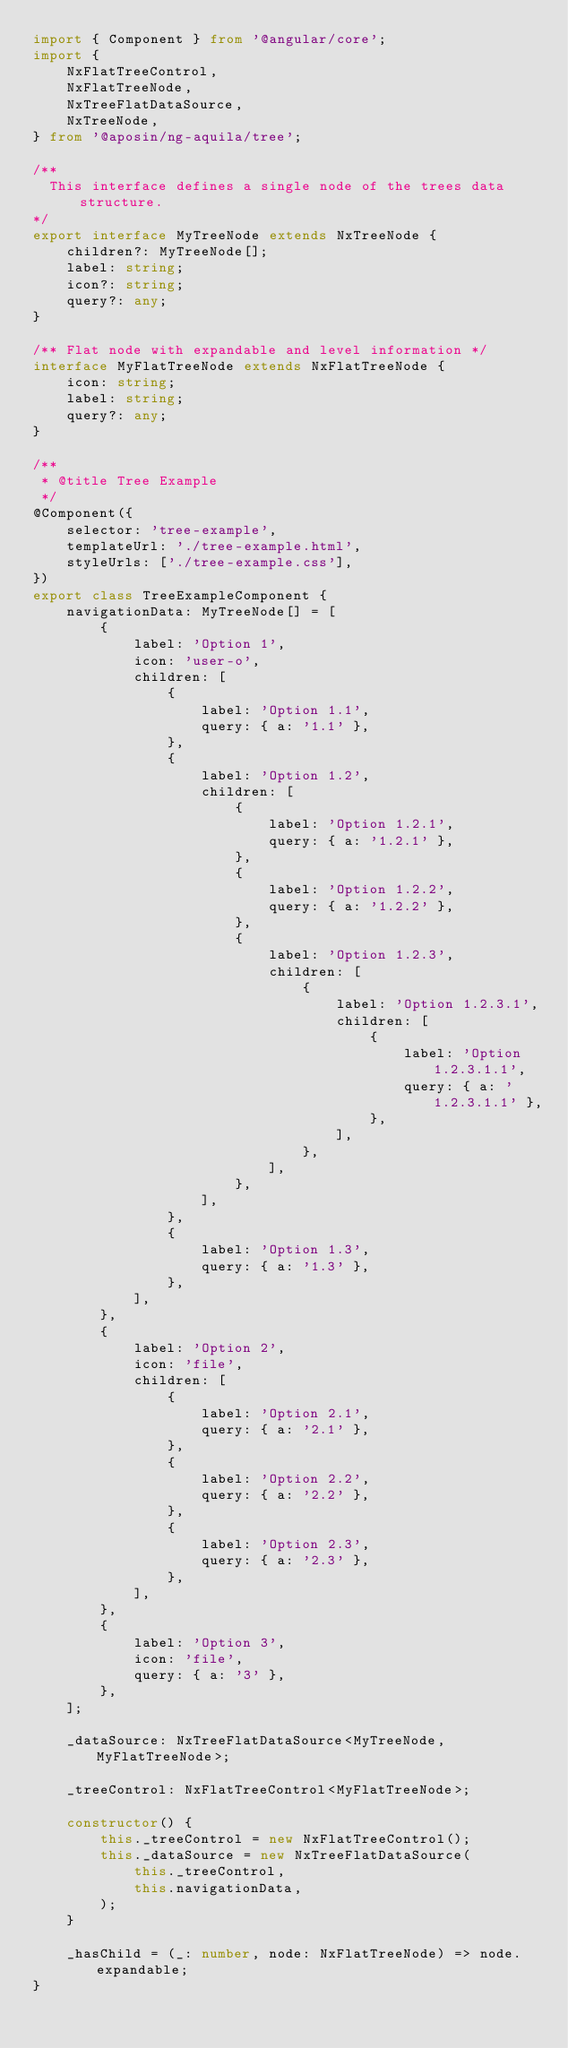Convert code to text. <code><loc_0><loc_0><loc_500><loc_500><_TypeScript_>import { Component } from '@angular/core';
import {
    NxFlatTreeControl,
    NxFlatTreeNode,
    NxTreeFlatDataSource,
    NxTreeNode,
} from '@aposin/ng-aquila/tree';

/**
  This interface defines a single node of the trees data structure.
*/
export interface MyTreeNode extends NxTreeNode {
    children?: MyTreeNode[];
    label: string;
    icon?: string;
    query?: any;
}

/** Flat node with expandable and level information */
interface MyFlatTreeNode extends NxFlatTreeNode {
    icon: string;
    label: string;
    query?: any;
}

/**
 * @title Tree Example
 */
@Component({
    selector: 'tree-example',
    templateUrl: './tree-example.html',
    styleUrls: ['./tree-example.css'],
})
export class TreeExampleComponent {
    navigationData: MyTreeNode[] = [
        {
            label: 'Option 1',
            icon: 'user-o',
            children: [
                {
                    label: 'Option 1.1',
                    query: { a: '1.1' },
                },
                {
                    label: 'Option 1.2',
                    children: [
                        {
                            label: 'Option 1.2.1',
                            query: { a: '1.2.1' },
                        },
                        {
                            label: 'Option 1.2.2',
                            query: { a: '1.2.2' },
                        },
                        {
                            label: 'Option 1.2.3',
                            children: [
                                {
                                    label: 'Option 1.2.3.1',
                                    children: [
                                        {
                                            label: 'Option 1.2.3.1.1',
                                            query: { a: '1.2.3.1.1' },
                                        },
                                    ],
                                },
                            ],
                        },
                    ],
                },
                {
                    label: 'Option 1.3',
                    query: { a: '1.3' },
                },
            ],
        },
        {
            label: 'Option 2',
            icon: 'file',
            children: [
                {
                    label: 'Option 2.1',
                    query: { a: '2.1' },
                },
                {
                    label: 'Option 2.2',
                    query: { a: '2.2' },
                },
                {
                    label: 'Option 2.3',
                    query: { a: '2.3' },
                },
            ],
        },
        {
            label: 'Option 3',
            icon: 'file',
            query: { a: '3' },
        },
    ];

    _dataSource: NxTreeFlatDataSource<MyTreeNode, MyFlatTreeNode>;

    _treeControl: NxFlatTreeControl<MyFlatTreeNode>;

    constructor() {
        this._treeControl = new NxFlatTreeControl();
        this._dataSource = new NxTreeFlatDataSource(
            this._treeControl,
            this.navigationData,
        );
    }

    _hasChild = (_: number, node: NxFlatTreeNode) => node.expandable;
}
</code> 